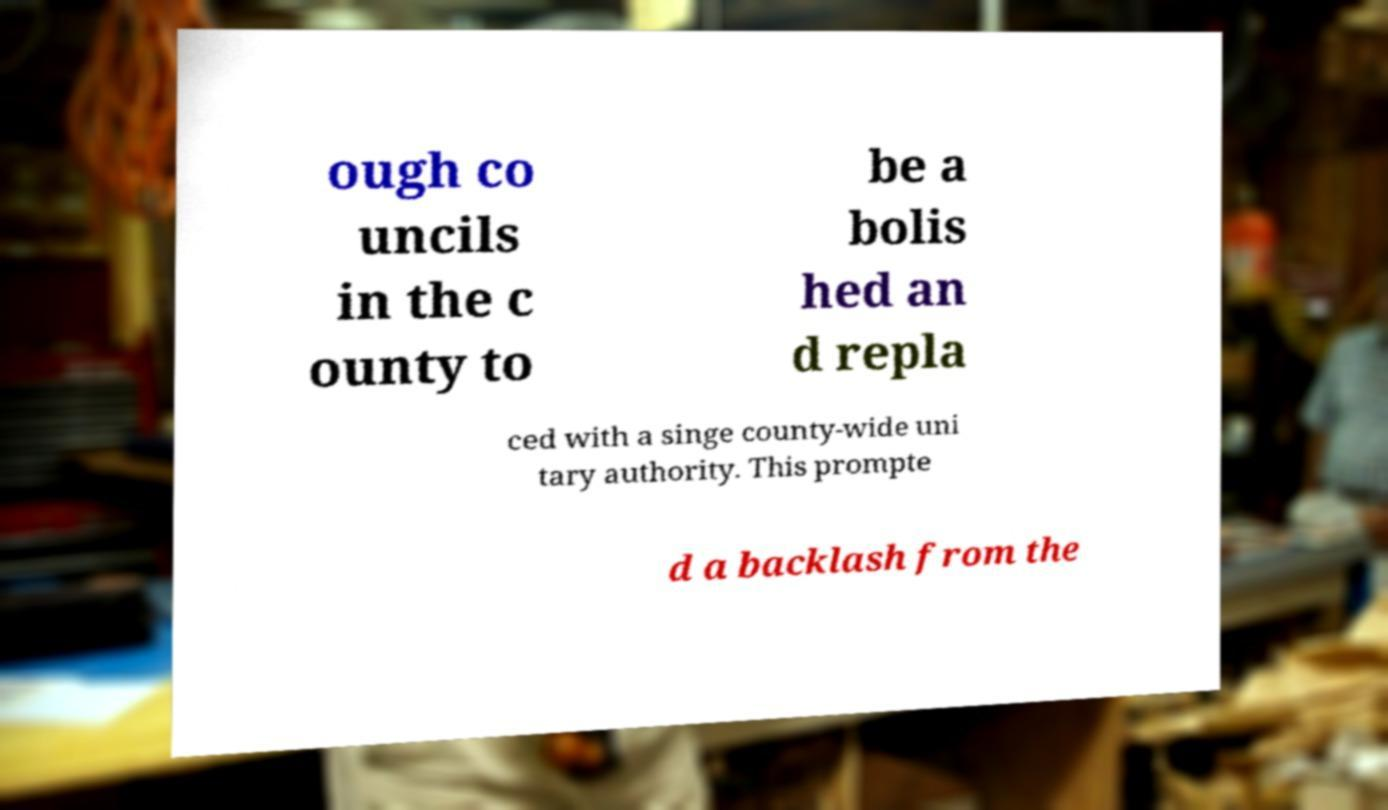I need the written content from this picture converted into text. Can you do that? ough co uncils in the c ounty to be a bolis hed an d repla ced with a singe county-wide uni tary authority. This prompte d a backlash from the 